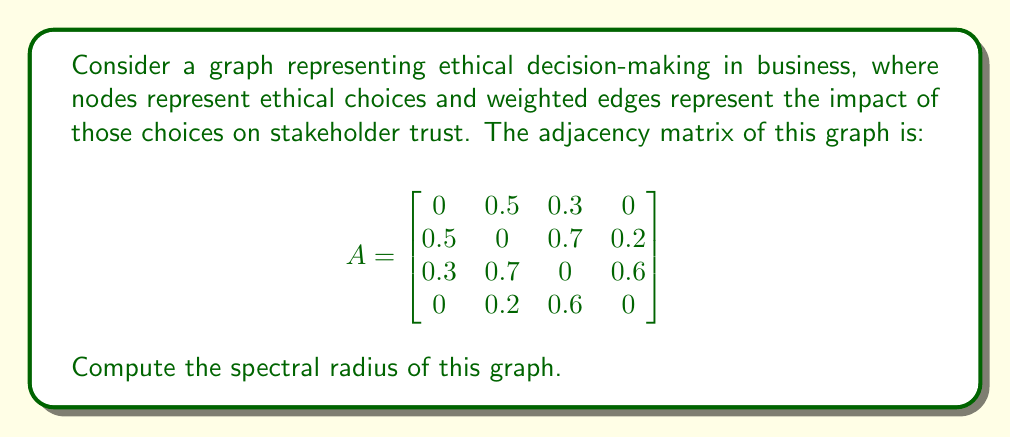Teach me how to tackle this problem. To find the spectral radius of the graph, we need to calculate the largest absolute eigenvalue of the adjacency matrix A.

Step 1: Characteristic polynomial
The characteristic polynomial is given by $det(A - \lambda I)$, where $I$ is the identity matrix.

$$det\begin{bmatrix}
-\lambda & 0.5 & 0.3 & 0 \\
0.5 & -\lambda & 0.7 & 0.2 \\
0.3 & 0.7 & -\lambda & 0.6 \\
0 & 0.2 & 0.6 & -\lambda
\end{bmatrix} = 0$$

Step 2: Solve the characteristic equation
Using a computer algebra system, we find the roots of the characteristic polynomial:

$\lambda_1 \approx 1.2915$
$\lambda_2 \approx -1.0377$
$\lambda_3 \approx -0.2538$
$\lambda_4 \approx 0$

Step 3: Find the spectral radius
The spectral radius is the largest absolute eigenvalue:

$\rho(A) = \max(|\lambda_1|, |\lambda_2|, |\lambda_3|, |\lambda_4|) = |\lambda_1| \approx 1.2915$

This value represents the maximum impact of ethical decisions on stakeholder trust in the business network.
Answer: $1.2915$ 